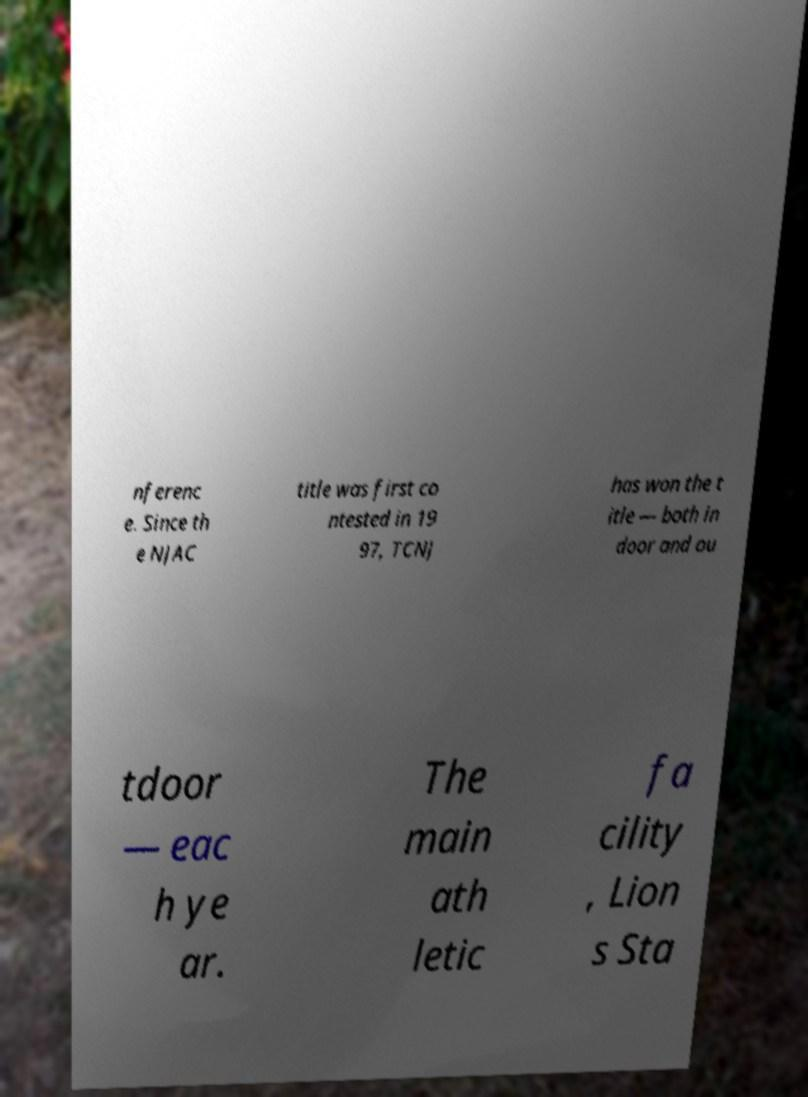For documentation purposes, I need the text within this image transcribed. Could you provide that? nferenc e. Since th e NJAC title was first co ntested in 19 97, TCNJ has won the t itle — both in door and ou tdoor — eac h ye ar. The main ath letic fa cility , Lion s Sta 